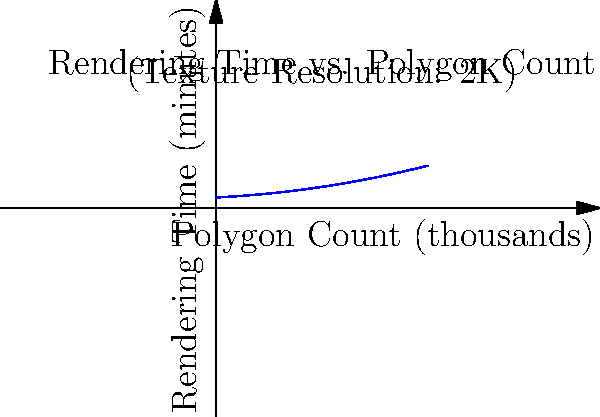In an open-source 3D rendering project for an anime scene, you're tasked with estimating the rendering time based on polygon count and texture resolution. Given the graph showing the relationship between polygon count and rendering time for a 2K texture resolution, estimate the rendering time for a scene with 150,000 polygons. How would this change if the texture resolution was increased to 4K, assuming a linear relationship between texture resolution and rendering time? Let's approach this step-by-step:

1. From the graph, we can estimate the rendering time for 150,000 polygons (150 on the x-axis) with 2K texture resolution:
   - Rendering time ≈ 55 minutes

2. To calculate the change for 4K texture resolution, we need to understand the relationship between texture resolution and rendering time:
   - Assume a linear relationship between texture resolution and rendering time
   - 2K to 4K is a doubling of resolution in each dimension, resulting in 4 times the number of pixels

3. Calculate the new rendering time for 4K texture resolution:
   - New rendering time = Original rendering time × 4
   - New rendering time = 55 minutes × 4 = 220 minutes

4. Calculate the difference:
   - Difference = New rendering time - Original rendering time
   - Difference = 220 minutes - 55 minutes = 165 minutes

Therefore, increasing the texture resolution from 2K to 4K would increase the rendering time by approximately 165 minutes.
Answer: 165 minutes 